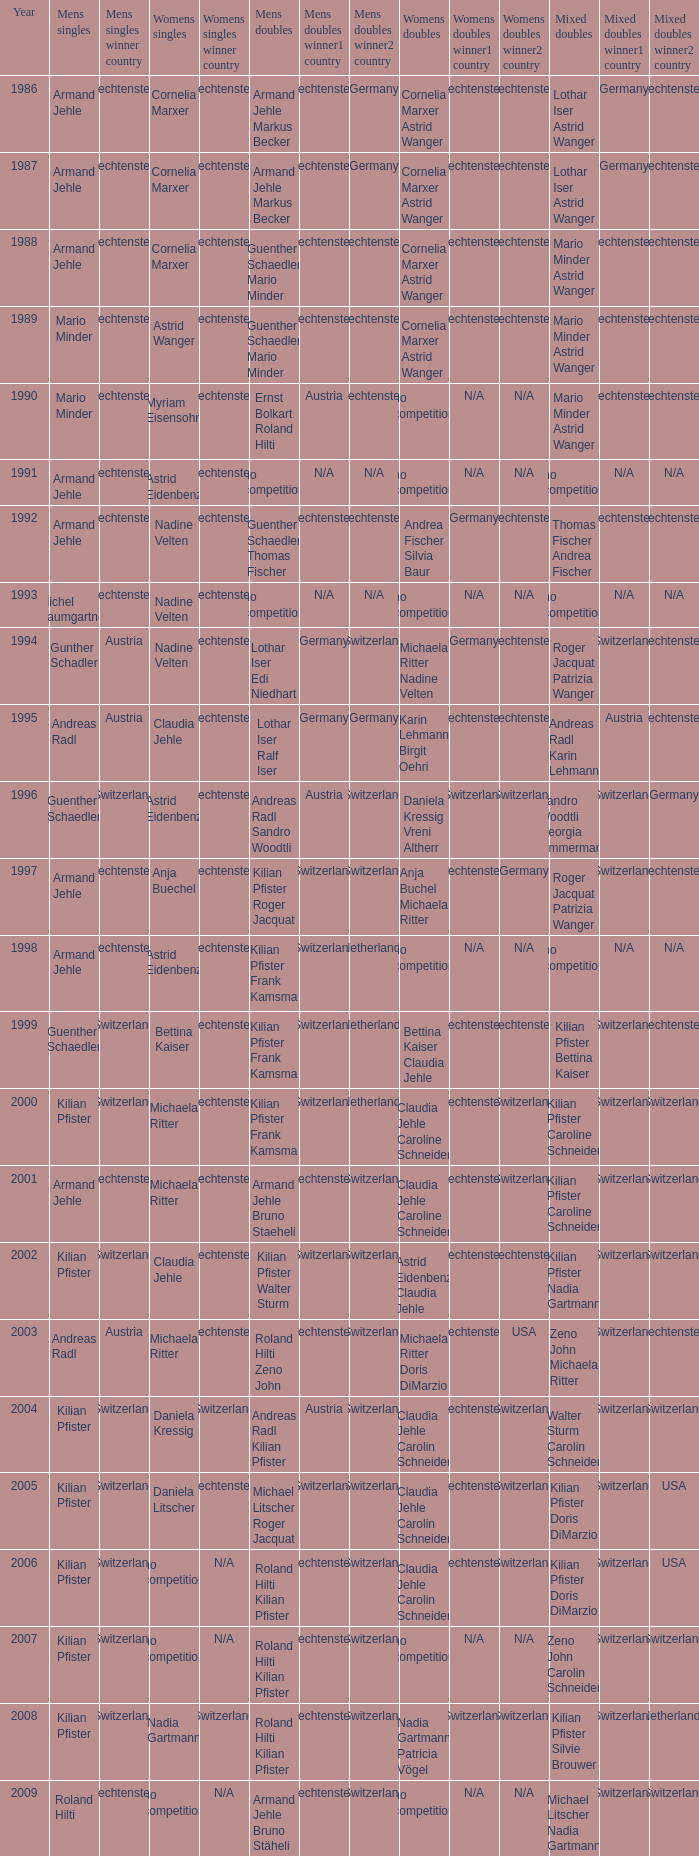In the year 2006, the womens singles had no competition and the mens doubles were roland hilti kilian pfister, what were the womens doubles Claudia Jehle Carolin Schneider. 